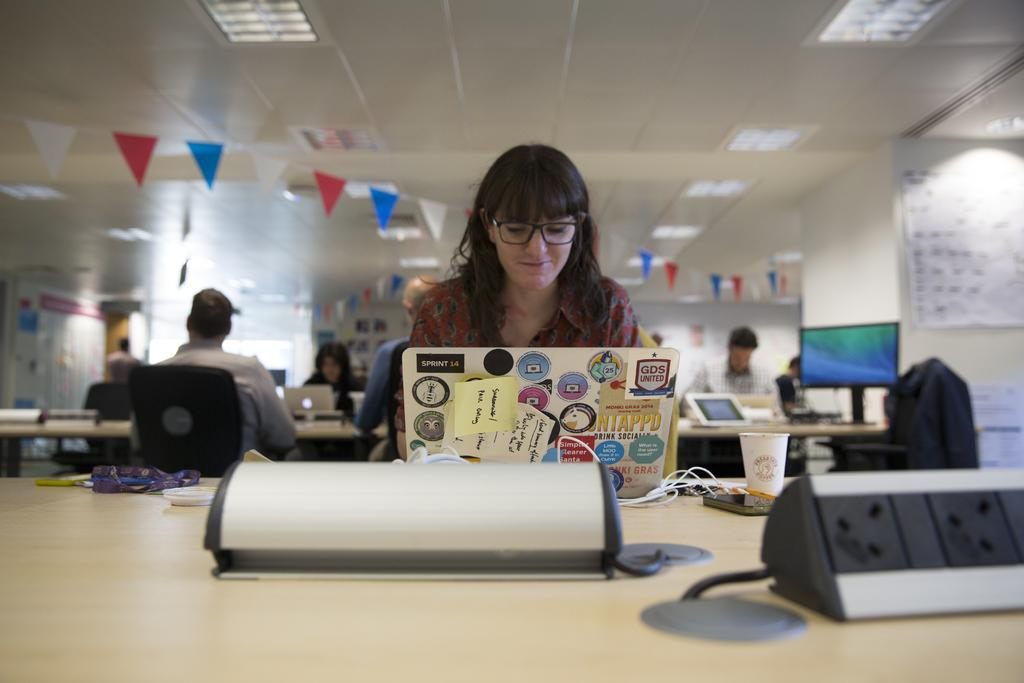What is the woman in the image doing? The woman is sitting in the image. What object is in front of the woman? The woman has a laptop in front of her. Can you describe the people in the background of the image? There are people sitting in the background of the image. How is the background of the image depicted? The background of the image is blurred. Reasoning: Let's think step by step by step in order to produce the conversation. We start by identifying the main subject in the image, which is the woman sitting. Then, we expand the conversation to include the object in front of her, which is a laptop. Next, we mention the people in the background and describe the background itself. Each question is designed to elicit a specific detail about the image that is known from the provided facts. Absurd Question/Answer: What type of owl can be seen sitting on the woman's shoulder in the image? There is no owl present in the image; the woman is sitting with a laptop in front of her. Is the woman using the laptop to communicate with her grandfather in the image? There is no information about the woman's grandfather or any communication in the image. What is the main subject of the image? The main subject of the image is a car. Can you describe the car in the image? The car is red and has four wheels. What can be seen in the background of the image? There is a road in the image. How is the road depicted in the image? The road is paved. Reasoning: Let's think step by step in order to produce the conversation. We start by identifying the main subject in the image, which is the car. Then, we expand the conversation to include the color and number of wheels of the car. Next, we mention the road in the background and describe its surface. Each question is designed to elicit a specific detail about the image that is known from the provided facts. Absurd Question/Answer: Can you tell me how many parrots are sitting on the car's roof in the image? There are no parrots present in the image; the car is 